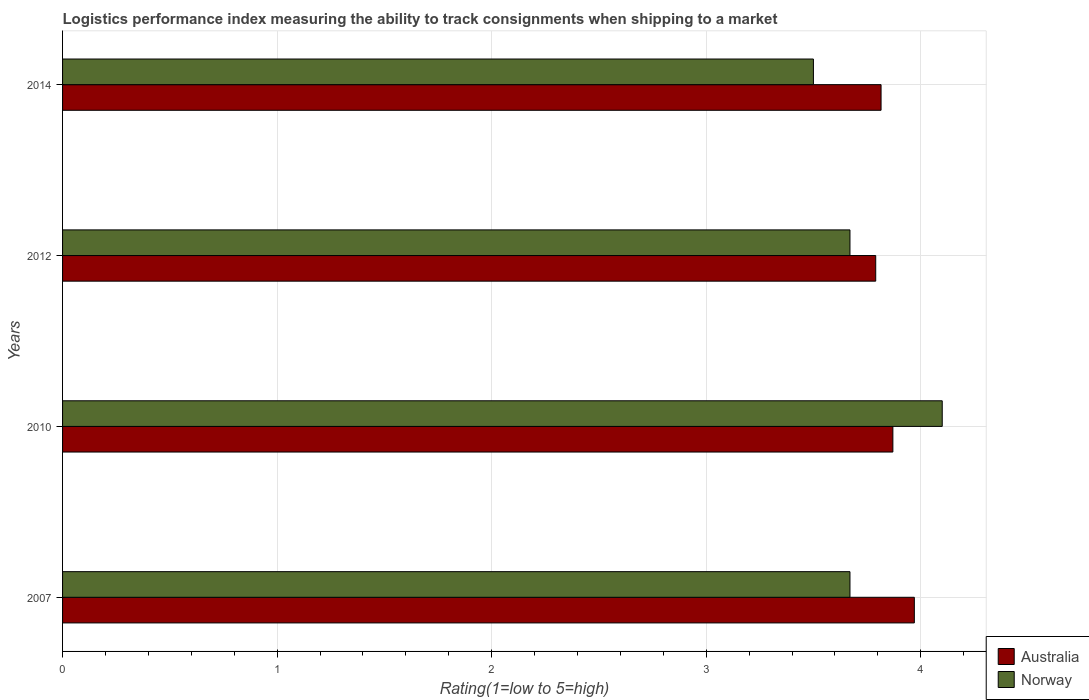How many different coloured bars are there?
Ensure brevity in your answer.  2. How many groups of bars are there?
Keep it short and to the point. 4. Are the number of bars per tick equal to the number of legend labels?
Keep it short and to the point. Yes. Are the number of bars on each tick of the Y-axis equal?
Your response must be concise. Yes. How many bars are there on the 4th tick from the bottom?
Provide a short and direct response. 2. What is the label of the 3rd group of bars from the top?
Keep it short and to the point. 2010. What is the Logistic performance index in Norway in 2010?
Provide a succinct answer. 4.1. Across all years, what is the maximum Logistic performance index in Australia?
Give a very brief answer. 3.97. Across all years, what is the minimum Logistic performance index in Australia?
Provide a short and direct response. 3.79. In which year was the Logistic performance index in Norway maximum?
Keep it short and to the point. 2010. What is the total Logistic performance index in Norway in the graph?
Your answer should be compact. 14.94. What is the difference between the Logistic performance index in Norway in 2010 and that in 2014?
Offer a terse response. 0.6. What is the difference between the Logistic performance index in Norway in 2010 and the Logistic performance index in Australia in 2007?
Give a very brief answer. 0.13. What is the average Logistic performance index in Norway per year?
Ensure brevity in your answer.  3.73. In the year 2014, what is the difference between the Logistic performance index in Australia and Logistic performance index in Norway?
Offer a very short reply. 0.32. In how many years, is the Logistic performance index in Australia greater than 0.8 ?
Your answer should be compact. 4. What is the ratio of the Logistic performance index in Norway in 2007 to that in 2010?
Keep it short and to the point. 0.9. Is the Logistic performance index in Norway in 2007 less than that in 2014?
Your answer should be very brief. No. Is the difference between the Logistic performance index in Australia in 2007 and 2010 greater than the difference between the Logistic performance index in Norway in 2007 and 2010?
Your answer should be compact. Yes. What is the difference between the highest and the second highest Logistic performance index in Australia?
Your response must be concise. 0.1. What is the difference between the highest and the lowest Logistic performance index in Australia?
Your answer should be very brief. 0.18. Is the sum of the Logistic performance index in Norway in 2010 and 2014 greater than the maximum Logistic performance index in Australia across all years?
Provide a succinct answer. Yes. What does the 1st bar from the top in 2010 represents?
Your response must be concise. Norway. How many bars are there?
Your response must be concise. 8. Are all the bars in the graph horizontal?
Your answer should be very brief. Yes. How many years are there in the graph?
Make the answer very short. 4. Are the values on the major ticks of X-axis written in scientific E-notation?
Your answer should be compact. No. Does the graph contain any zero values?
Make the answer very short. No. How many legend labels are there?
Keep it short and to the point. 2. What is the title of the graph?
Offer a terse response. Logistics performance index measuring the ability to track consignments when shipping to a market. Does "Peru" appear as one of the legend labels in the graph?
Make the answer very short. No. What is the label or title of the X-axis?
Give a very brief answer. Rating(1=low to 5=high). What is the label or title of the Y-axis?
Keep it short and to the point. Years. What is the Rating(1=low to 5=high) of Australia in 2007?
Make the answer very short. 3.97. What is the Rating(1=low to 5=high) in Norway in 2007?
Your answer should be very brief. 3.67. What is the Rating(1=low to 5=high) of Australia in 2010?
Offer a terse response. 3.87. What is the Rating(1=low to 5=high) in Australia in 2012?
Ensure brevity in your answer.  3.79. What is the Rating(1=low to 5=high) of Norway in 2012?
Ensure brevity in your answer.  3.67. What is the Rating(1=low to 5=high) of Australia in 2014?
Give a very brief answer. 3.81. What is the Rating(1=low to 5=high) in Norway in 2014?
Make the answer very short. 3.5. Across all years, what is the maximum Rating(1=low to 5=high) of Australia?
Your answer should be very brief. 3.97. Across all years, what is the minimum Rating(1=low to 5=high) in Australia?
Keep it short and to the point. 3.79. Across all years, what is the minimum Rating(1=low to 5=high) in Norway?
Give a very brief answer. 3.5. What is the total Rating(1=low to 5=high) in Australia in the graph?
Your response must be concise. 15.44. What is the total Rating(1=low to 5=high) in Norway in the graph?
Keep it short and to the point. 14.94. What is the difference between the Rating(1=low to 5=high) in Australia in 2007 and that in 2010?
Your answer should be compact. 0.1. What is the difference between the Rating(1=low to 5=high) of Norway in 2007 and that in 2010?
Make the answer very short. -0.43. What is the difference between the Rating(1=low to 5=high) of Australia in 2007 and that in 2012?
Your response must be concise. 0.18. What is the difference between the Rating(1=low to 5=high) of Norway in 2007 and that in 2012?
Give a very brief answer. 0. What is the difference between the Rating(1=low to 5=high) of Australia in 2007 and that in 2014?
Give a very brief answer. 0.16. What is the difference between the Rating(1=low to 5=high) of Norway in 2007 and that in 2014?
Your answer should be compact. 0.17. What is the difference between the Rating(1=low to 5=high) of Norway in 2010 and that in 2012?
Make the answer very short. 0.43. What is the difference between the Rating(1=low to 5=high) in Australia in 2010 and that in 2014?
Your response must be concise. 0.06. What is the difference between the Rating(1=low to 5=high) in Norway in 2010 and that in 2014?
Your answer should be compact. 0.6. What is the difference between the Rating(1=low to 5=high) of Australia in 2012 and that in 2014?
Make the answer very short. -0.02. What is the difference between the Rating(1=low to 5=high) in Norway in 2012 and that in 2014?
Your answer should be very brief. 0.17. What is the difference between the Rating(1=low to 5=high) in Australia in 2007 and the Rating(1=low to 5=high) in Norway in 2010?
Give a very brief answer. -0.13. What is the difference between the Rating(1=low to 5=high) in Australia in 2007 and the Rating(1=low to 5=high) in Norway in 2014?
Ensure brevity in your answer.  0.47. What is the difference between the Rating(1=low to 5=high) in Australia in 2010 and the Rating(1=low to 5=high) in Norway in 2012?
Give a very brief answer. 0.2. What is the difference between the Rating(1=low to 5=high) of Australia in 2010 and the Rating(1=low to 5=high) of Norway in 2014?
Offer a very short reply. 0.37. What is the difference between the Rating(1=low to 5=high) in Australia in 2012 and the Rating(1=low to 5=high) in Norway in 2014?
Keep it short and to the point. 0.29. What is the average Rating(1=low to 5=high) of Australia per year?
Offer a very short reply. 3.86. What is the average Rating(1=low to 5=high) of Norway per year?
Make the answer very short. 3.73. In the year 2007, what is the difference between the Rating(1=low to 5=high) of Australia and Rating(1=low to 5=high) of Norway?
Your answer should be very brief. 0.3. In the year 2010, what is the difference between the Rating(1=low to 5=high) in Australia and Rating(1=low to 5=high) in Norway?
Your answer should be very brief. -0.23. In the year 2012, what is the difference between the Rating(1=low to 5=high) of Australia and Rating(1=low to 5=high) of Norway?
Provide a short and direct response. 0.12. In the year 2014, what is the difference between the Rating(1=low to 5=high) in Australia and Rating(1=low to 5=high) in Norway?
Provide a short and direct response. 0.32. What is the ratio of the Rating(1=low to 5=high) in Australia in 2007 to that in 2010?
Give a very brief answer. 1.03. What is the ratio of the Rating(1=low to 5=high) of Norway in 2007 to that in 2010?
Ensure brevity in your answer.  0.9. What is the ratio of the Rating(1=low to 5=high) in Australia in 2007 to that in 2012?
Your answer should be very brief. 1.05. What is the ratio of the Rating(1=low to 5=high) in Australia in 2007 to that in 2014?
Provide a succinct answer. 1.04. What is the ratio of the Rating(1=low to 5=high) in Norway in 2007 to that in 2014?
Offer a very short reply. 1.05. What is the ratio of the Rating(1=low to 5=high) in Australia in 2010 to that in 2012?
Make the answer very short. 1.02. What is the ratio of the Rating(1=low to 5=high) in Norway in 2010 to that in 2012?
Your response must be concise. 1.12. What is the ratio of the Rating(1=low to 5=high) of Australia in 2010 to that in 2014?
Provide a succinct answer. 1.01. What is the ratio of the Rating(1=low to 5=high) in Norway in 2010 to that in 2014?
Provide a short and direct response. 1.17. What is the ratio of the Rating(1=low to 5=high) of Australia in 2012 to that in 2014?
Provide a short and direct response. 0.99. What is the ratio of the Rating(1=low to 5=high) of Norway in 2012 to that in 2014?
Your answer should be very brief. 1.05. What is the difference between the highest and the second highest Rating(1=low to 5=high) of Norway?
Your answer should be compact. 0.43. What is the difference between the highest and the lowest Rating(1=low to 5=high) in Australia?
Provide a short and direct response. 0.18. What is the difference between the highest and the lowest Rating(1=low to 5=high) in Norway?
Provide a short and direct response. 0.6. 